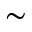<formula> <loc_0><loc_0><loc_500><loc_500>\sim</formula> 